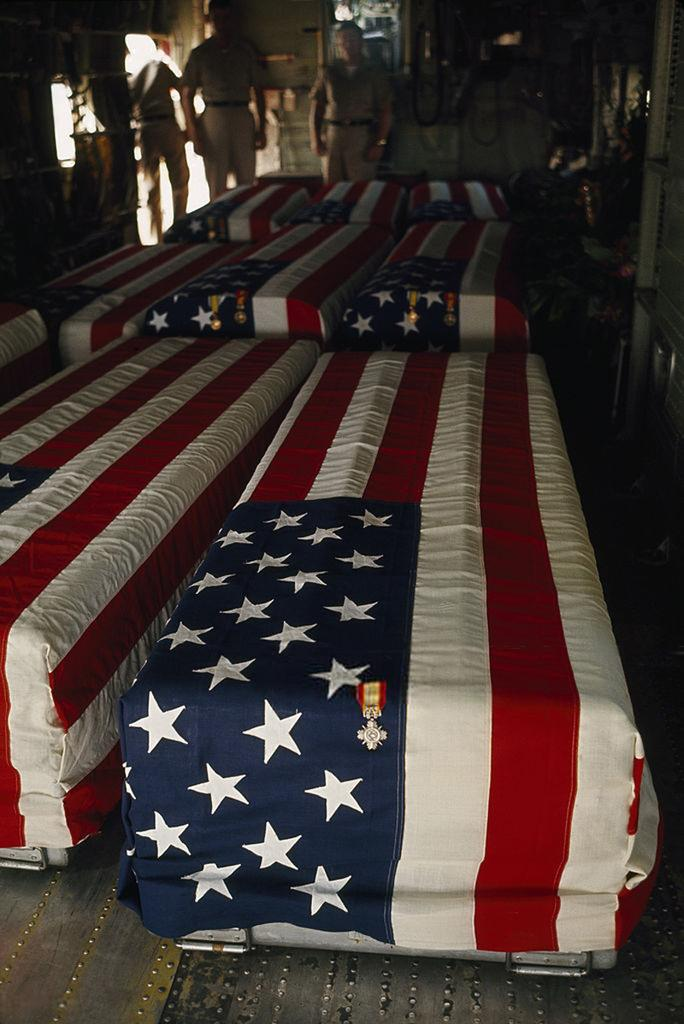What objects are present in the image? There are boxes in the image. How are the boxes decorated? The boxes are covered with flags. What can be seen in the background of the image? There is a group of people in the background of the image. How many kittens are sitting on top of the boxes in the image? There are no kittens present in the image; it only features boxes covered with flags and a group of people in the background. 